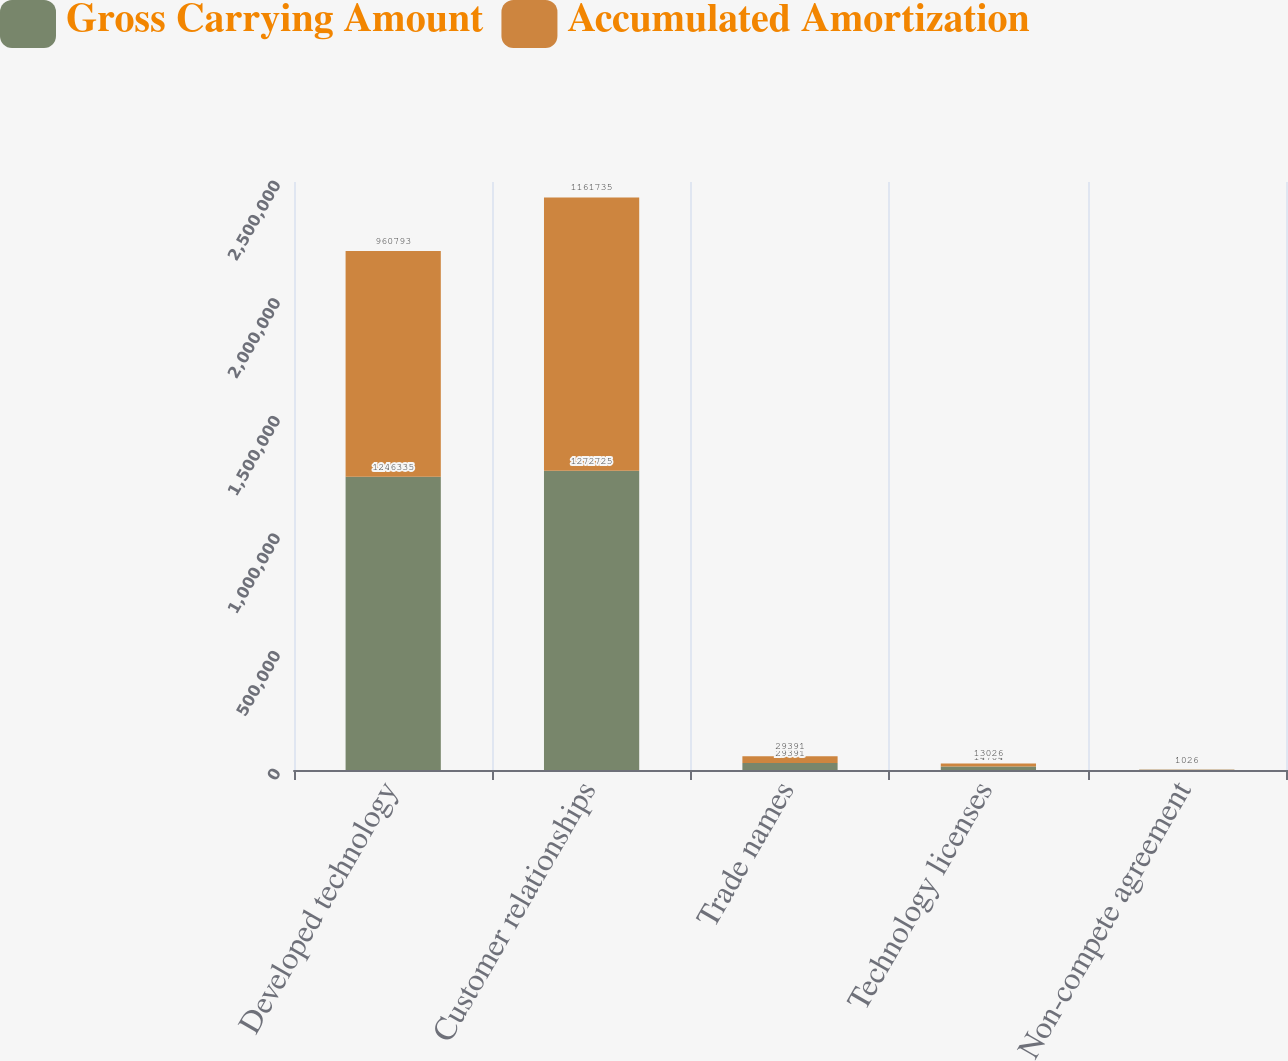Convert chart. <chart><loc_0><loc_0><loc_500><loc_500><stacked_bar_chart><ecel><fcel>Developed technology<fcel>Customer relationships<fcel>Trade names<fcel>Technology licenses<fcel>Non-compete agreement<nl><fcel>Gross Carrying Amount<fcel>1.24634e+06<fcel>1.27272e+06<fcel>29391<fcel>14704<fcel>1026<nl><fcel>Accumulated Amortization<fcel>960793<fcel>1.16174e+06<fcel>29391<fcel>13026<fcel>1026<nl></chart> 